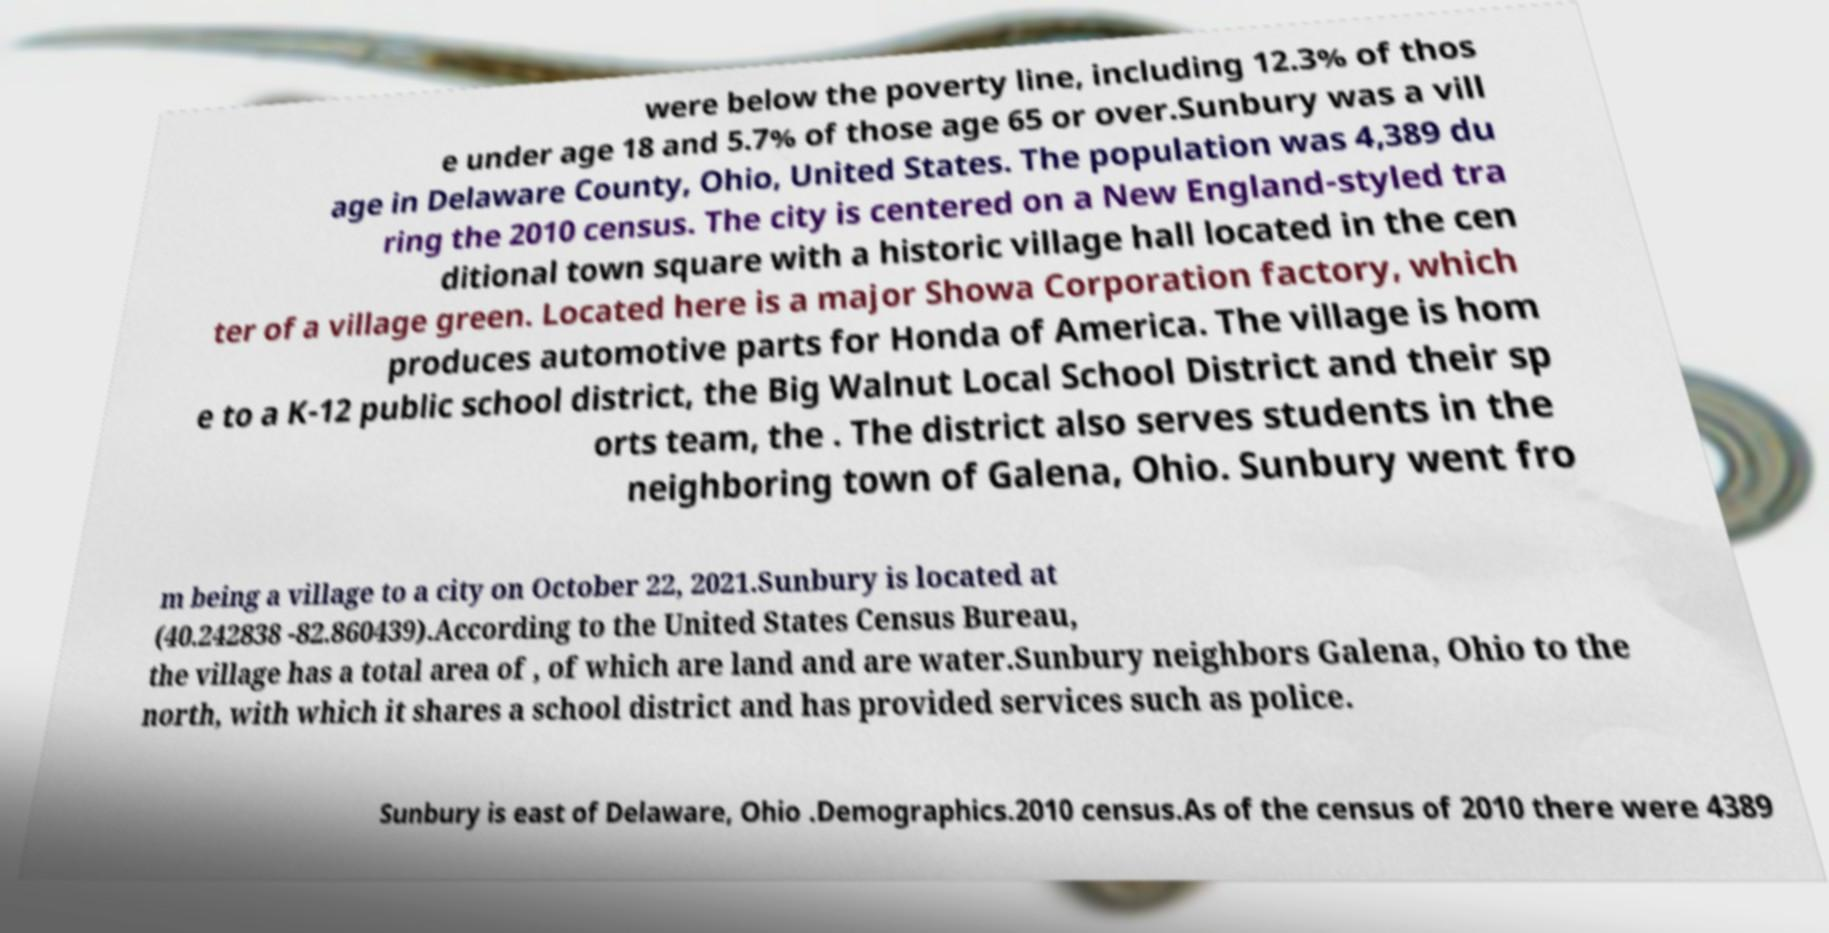Can you accurately transcribe the text from the provided image for me? were below the poverty line, including 12.3% of thos e under age 18 and 5.7% of those age 65 or over.Sunbury was a vill age in Delaware County, Ohio, United States. The population was 4,389 du ring the 2010 census. The city is centered on a New England-styled tra ditional town square with a historic village hall located in the cen ter of a village green. Located here is a major Showa Corporation factory, which produces automotive parts for Honda of America. The village is hom e to a K-12 public school district, the Big Walnut Local School District and their sp orts team, the . The district also serves students in the neighboring town of Galena, Ohio. Sunbury went fro m being a village to a city on October 22, 2021.Sunbury is located at (40.242838 -82.860439).According to the United States Census Bureau, the village has a total area of , of which are land and are water.Sunbury neighbors Galena, Ohio to the north, with which it shares a school district and has provided services such as police. Sunbury is east of Delaware, Ohio .Demographics.2010 census.As of the census of 2010 there were 4389 